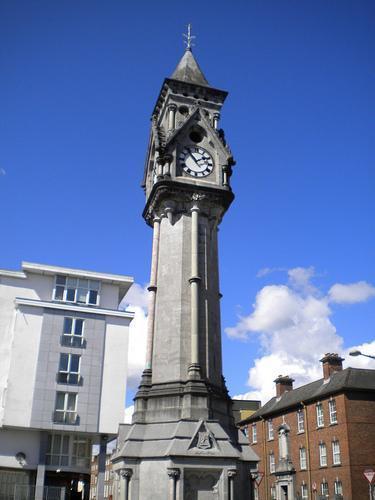How many buildings are in the photo?
Give a very brief answer. 2. 